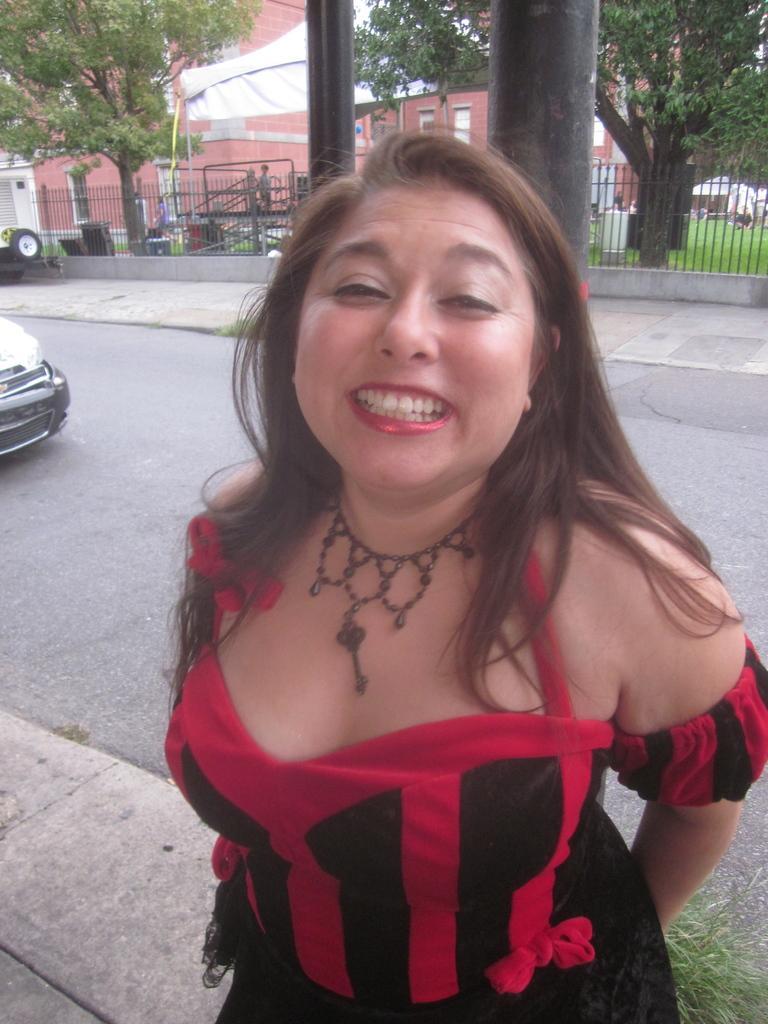Could you give a brief overview of what you see in this image? In this picture I can see a woman standing and smiling, there is a vehicle on the road, there are iron grilles, trees, there are group of people, there is a building and a tent. 